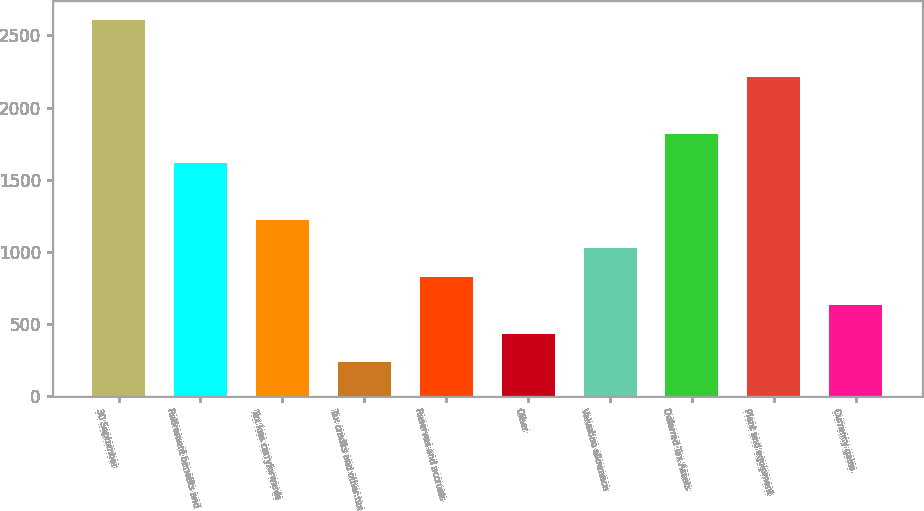<chart> <loc_0><loc_0><loc_500><loc_500><bar_chart><fcel>30 September<fcel>Retirement benefits and<fcel>Tax loss carryforwards<fcel>Tax credits and other tax<fcel>Reserves and accruals<fcel>Other<fcel>Valuation allowance<fcel>Deferred Tax Assets<fcel>Plant and equipment<fcel>Currency gains<nl><fcel>2609.21<fcel>1618.86<fcel>1222.72<fcel>232.37<fcel>826.58<fcel>430.44<fcel>1024.65<fcel>1816.93<fcel>2213.07<fcel>628.51<nl></chart> 